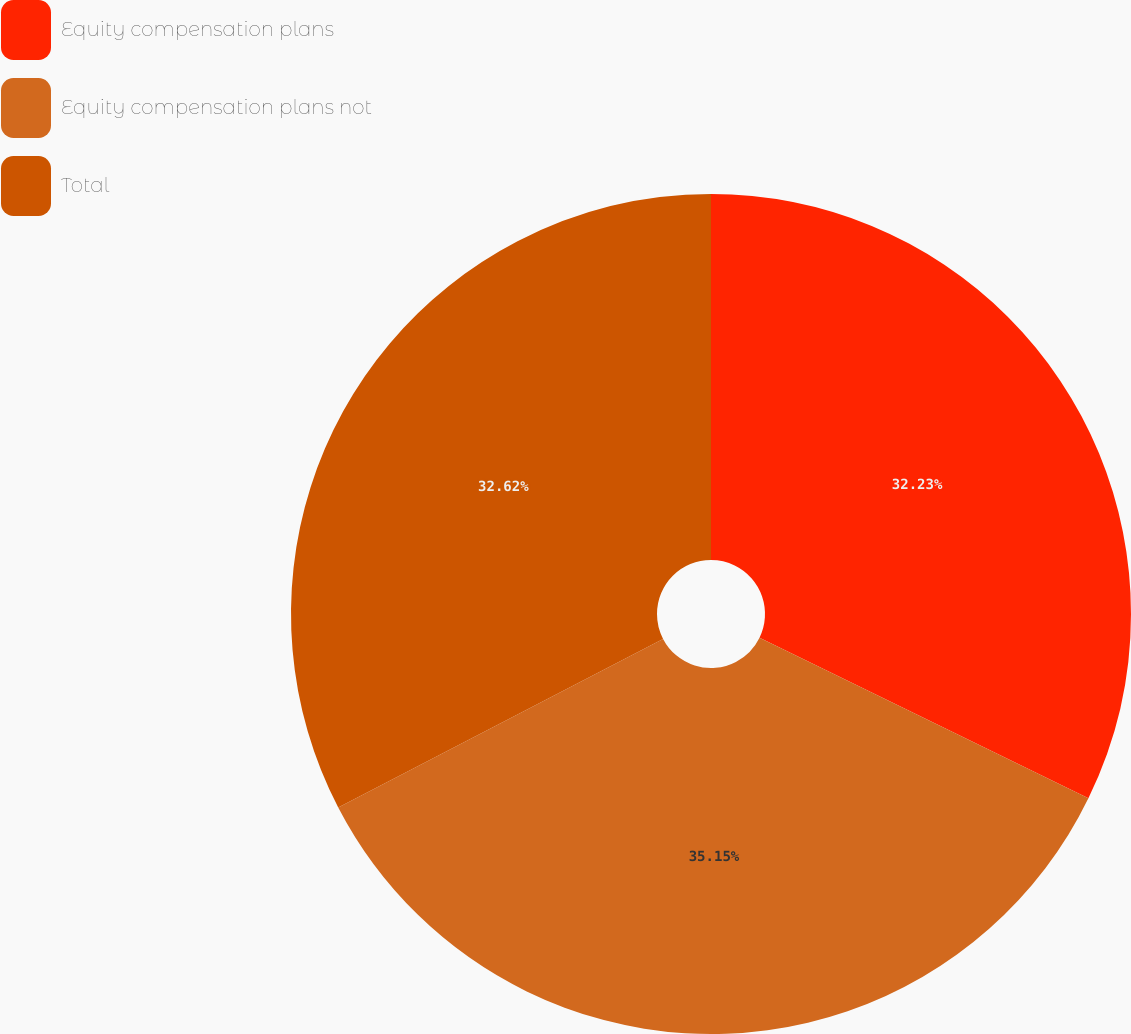Convert chart to OTSL. <chart><loc_0><loc_0><loc_500><loc_500><pie_chart><fcel>Equity compensation plans<fcel>Equity compensation plans not<fcel>Total<nl><fcel>32.23%<fcel>35.15%<fcel>32.62%<nl></chart> 